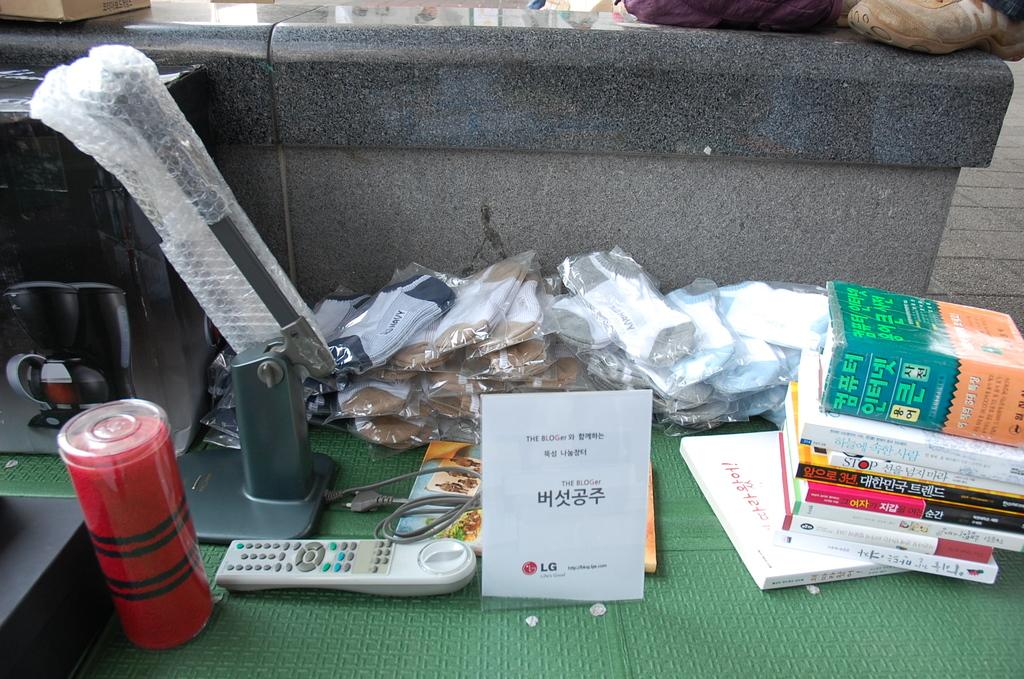<image>
Relay a brief, clear account of the picture shown. A miscellaneous of items one being a manual for the BLOGer 